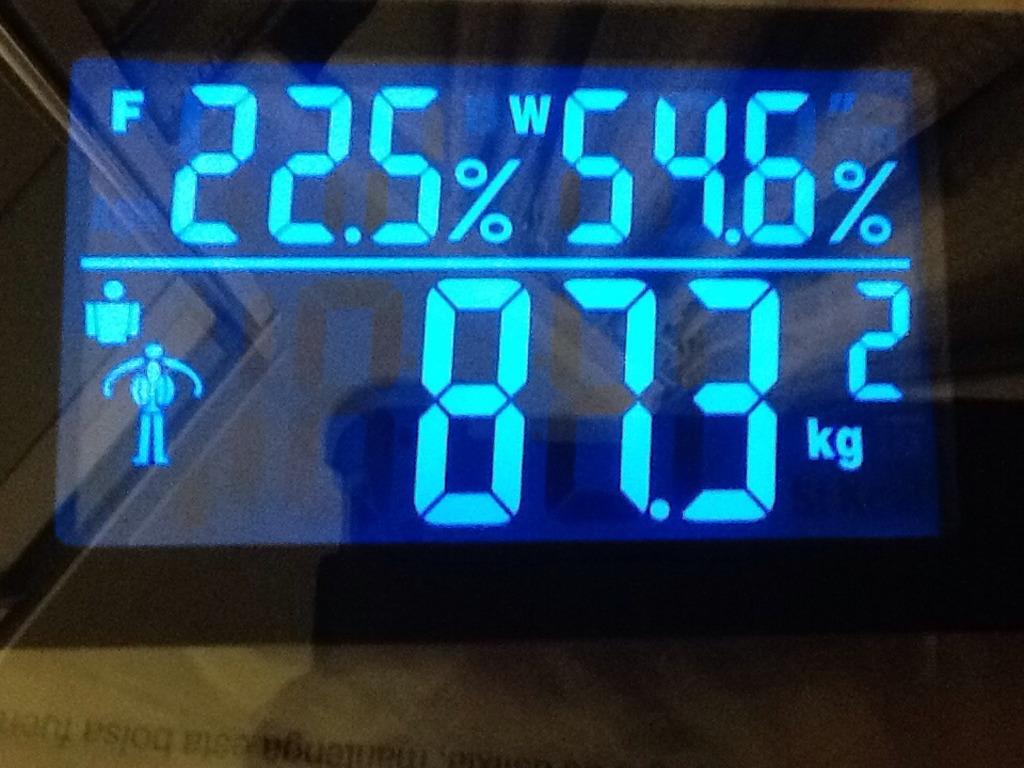What percentage is on the right?
Ensure brevity in your answer.  54.6%. 